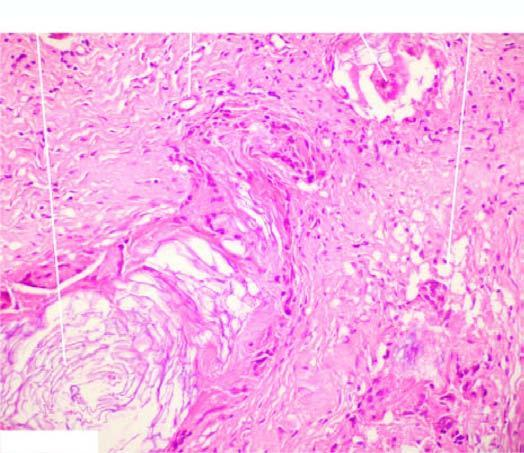s there chronic inflammatory granulation tissue and foreign body giant cells around the cholesterol clefts and some pink keratinous material?
Answer the question using a single word or phrase. Yes 